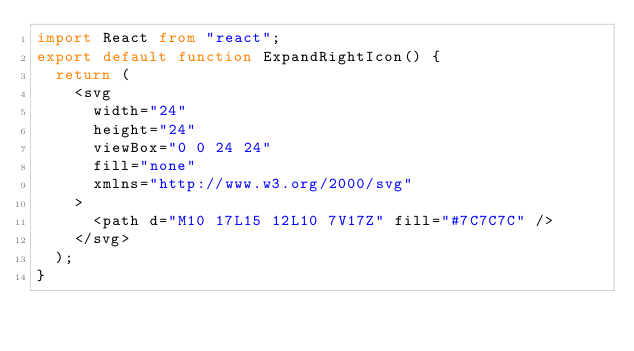Convert code to text. <code><loc_0><loc_0><loc_500><loc_500><_TypeScript_>import React from "react";
export default function ExpandRightIcon() {
  return (
    <svg
      width="24"
      height="24"
      viewBox="0 0 24 24"
      fill="none"
      xmlns="http://www.w3.org/2000/svg"
    >
      <path d="M10 17L15 12L10 7V17Z" fill="#7C7C7C" />
    </svg>
  );
}
</code> 